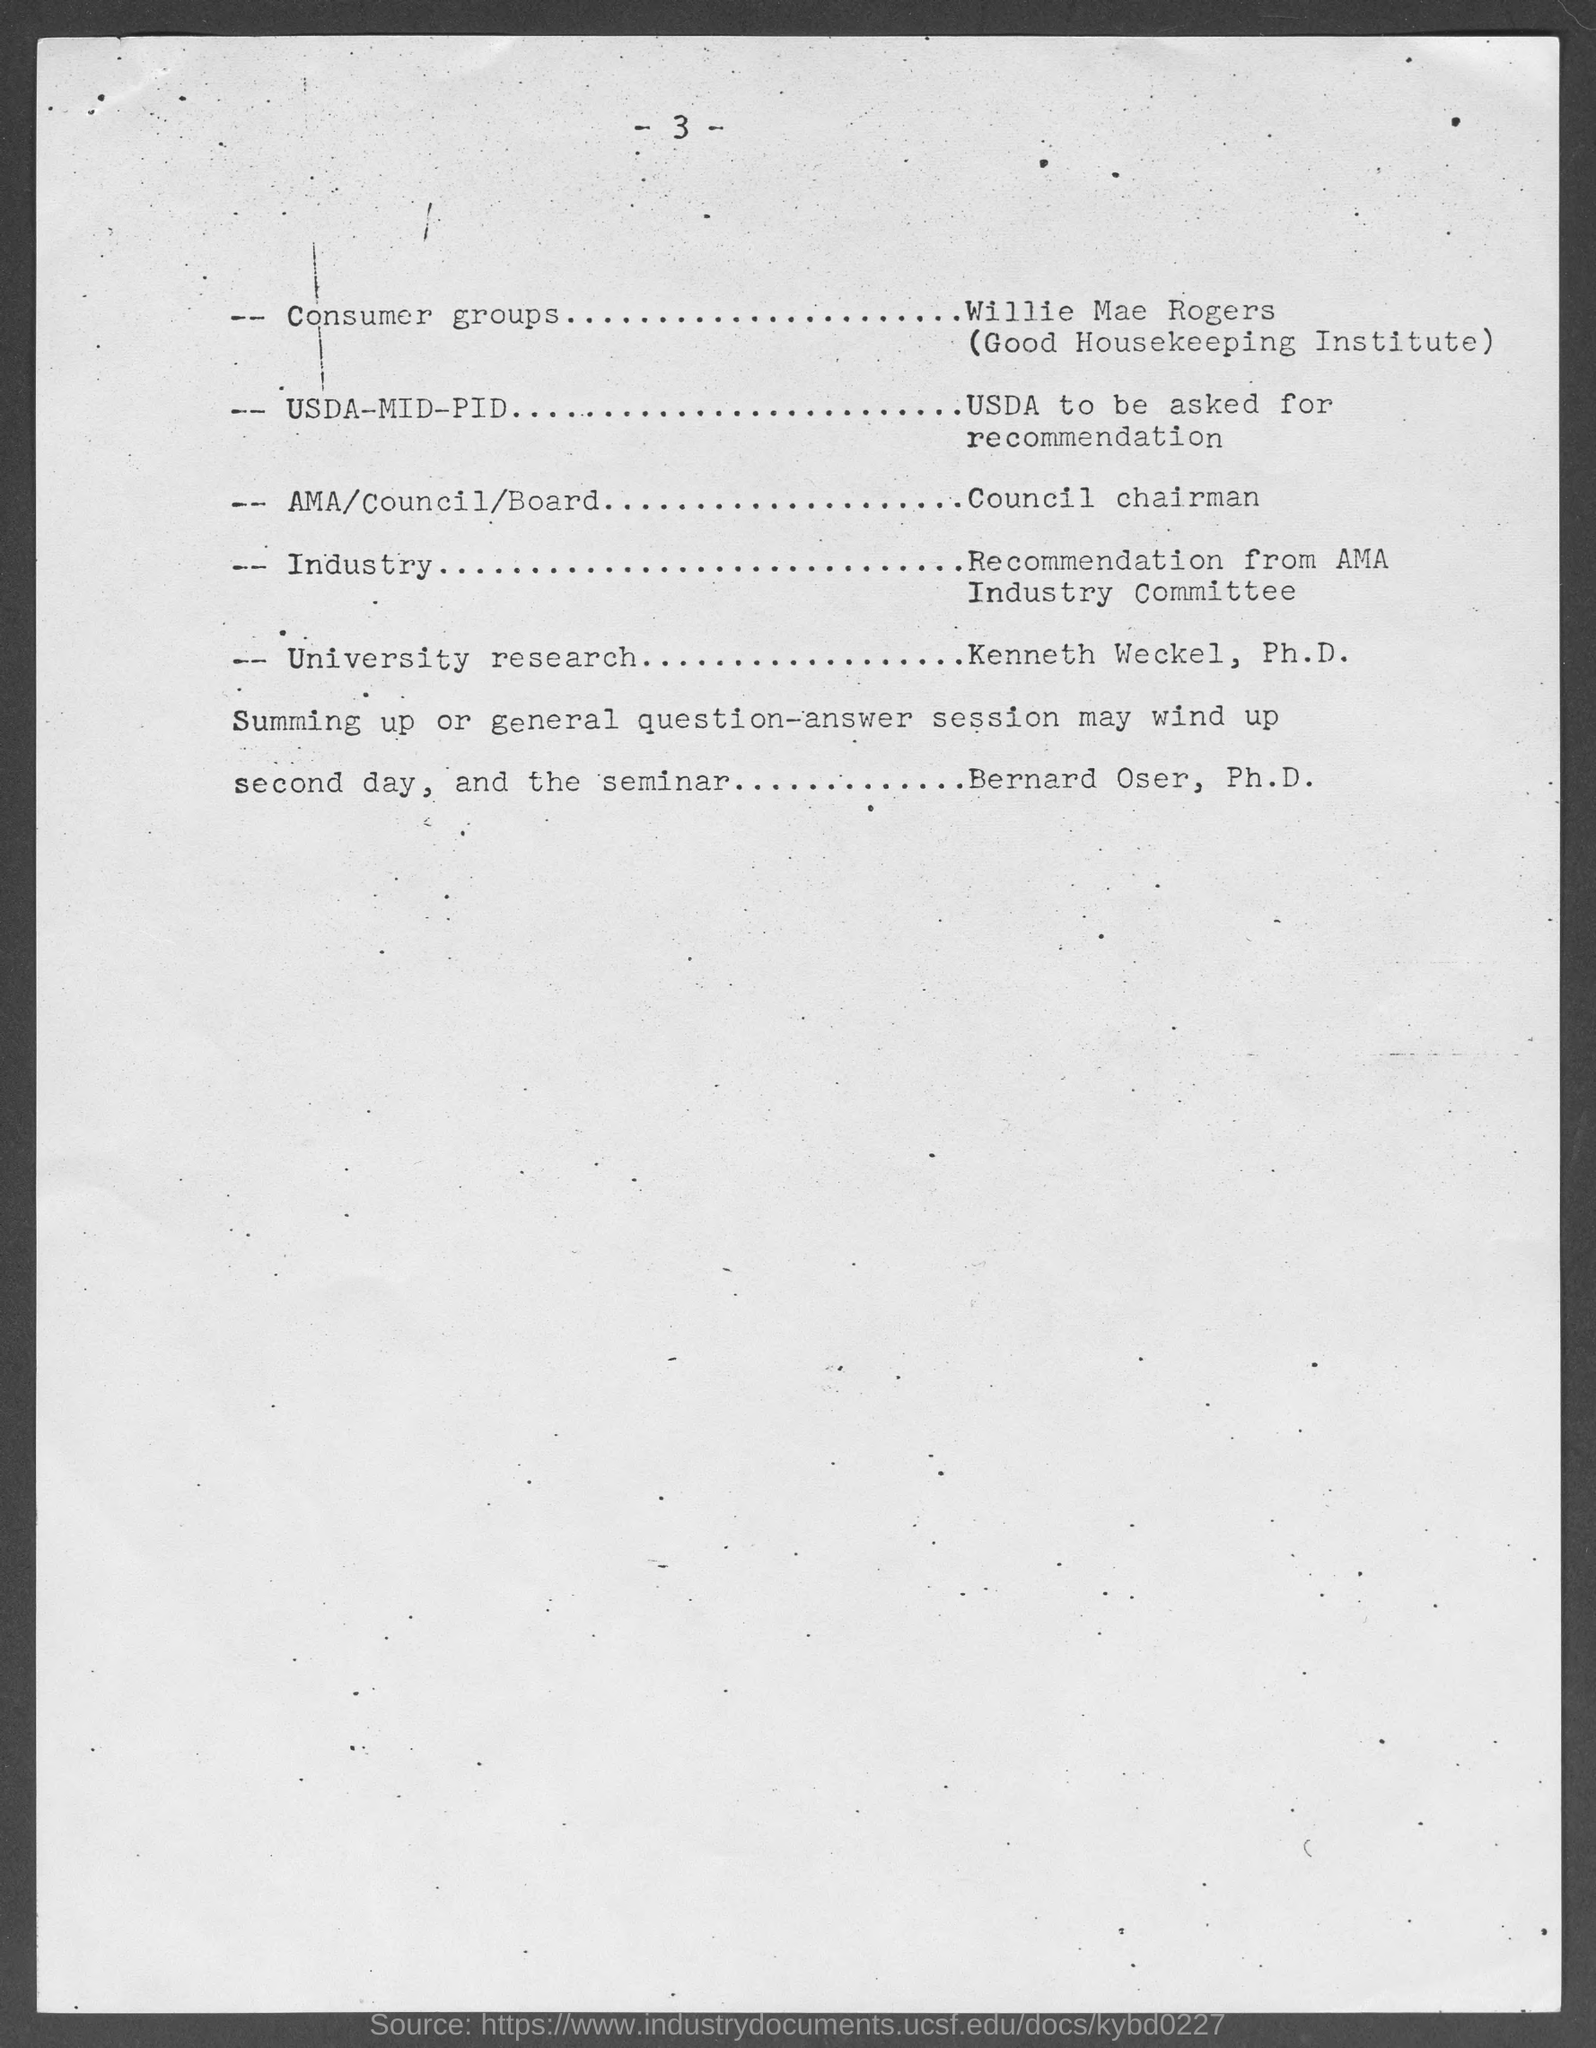What is the page number at top of the page?
Your answer should be compact. -3-. 